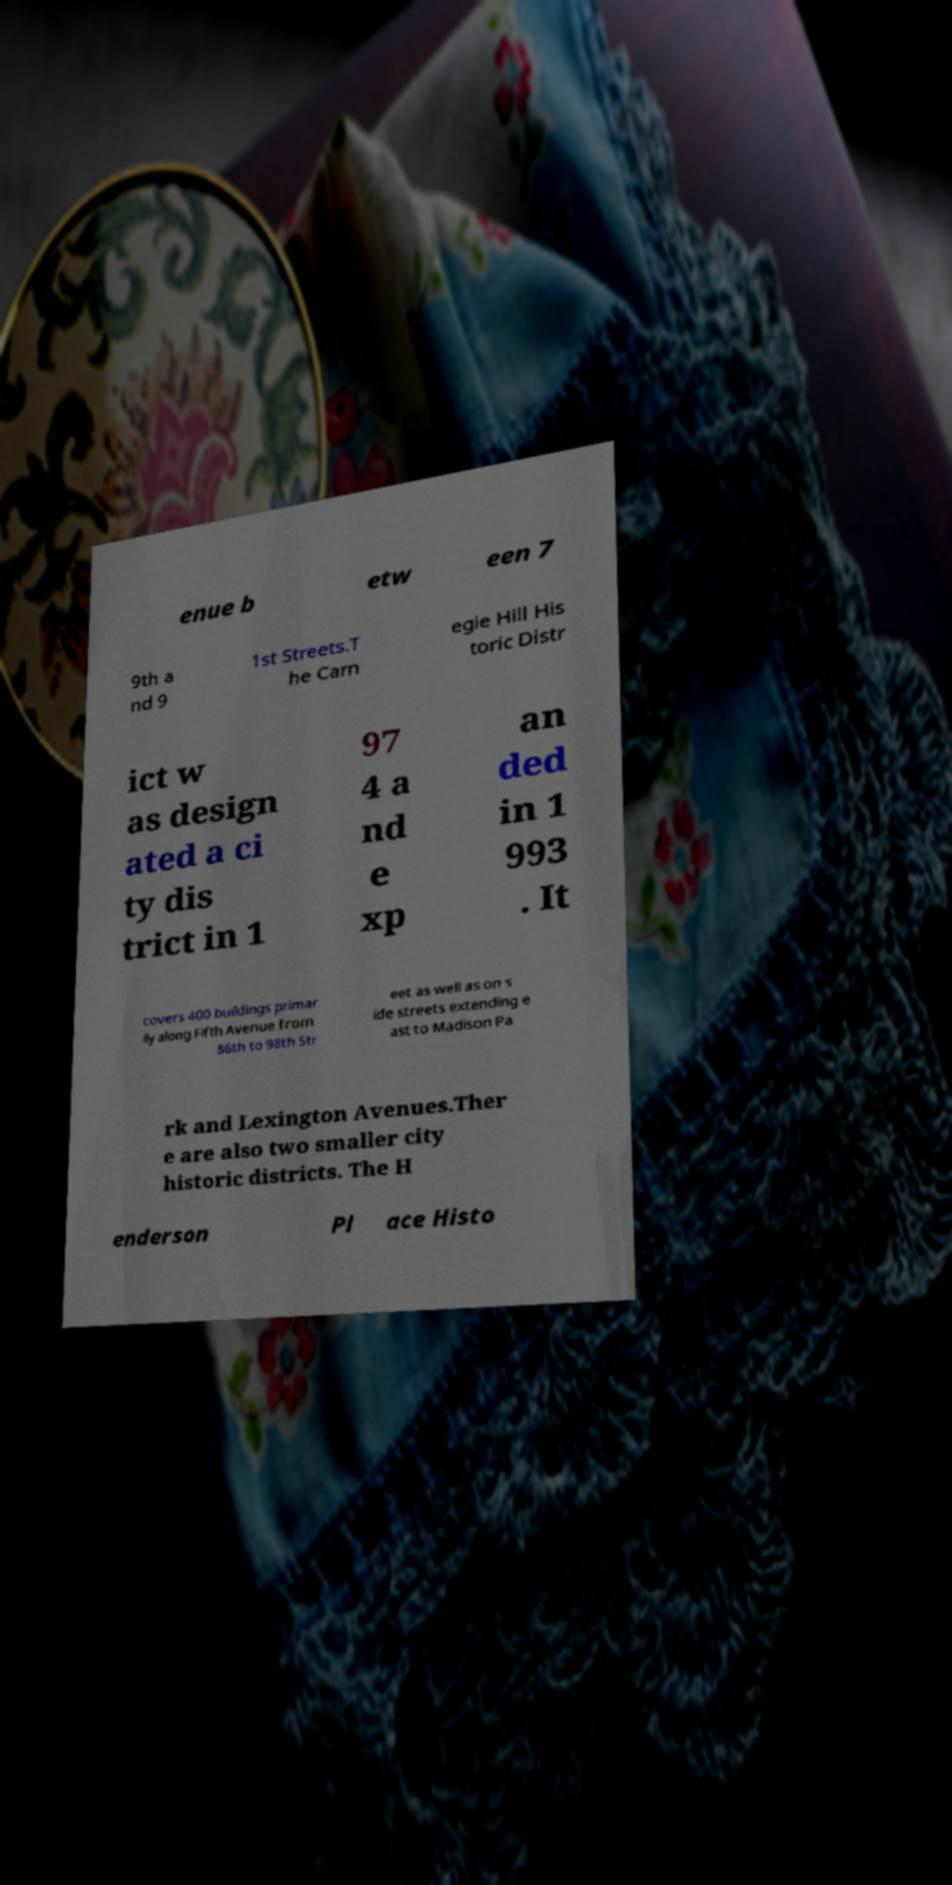Please identify and transcribe the text found in this image. enue b etw een 7 9th a nd 9 1st Streets.T he Carn egie Hill His toric Distr ict w as design ated a ci ty dis trict in 1 97 4 a nd e xp an ded in 1 993 . It covers 400 buildings primar ily along Fifth Avenue from 86th to 98th Str eet as well as on s ide streets extending e ast to Madison Pa rk and Lexington Avenues.Ther e are also two smaller city historic districts. The H enderson Pl ace Histo 